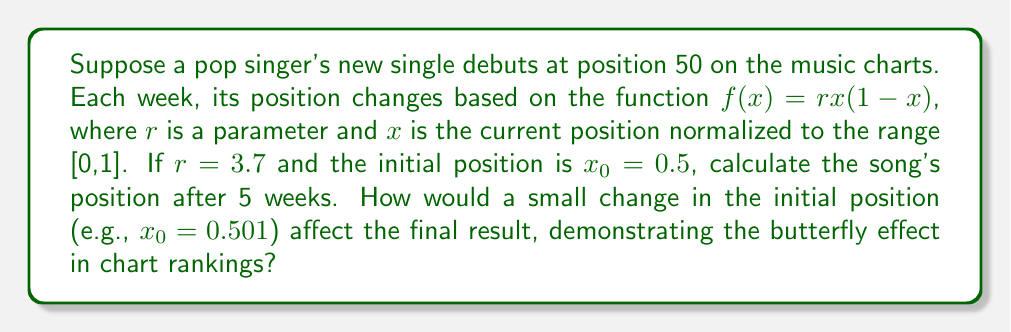Give your solution to this math problem. 1. Normalize the initial position:
   $x_0 = 50/100 = 0.5$

2. Use the logistic map equation $x_{n+1} = rx_n(1-x_n)$ with $r = 3.7$:

   Week 1: $x_1 = 3.7 \cdot 0.5 \cdot (1-0.5) = 0.925$
   Week 2: $x_2 = 3.7 \cdot 0.925 \cdot (1-0.925) = 0.256$
   Week 3: $x_3 = 3.7 \cdot 0.256 \cdot (1-0.256) = 0.706$
   Week 4: $x_4 = 3.7 \cdot 0.706 \cdot (1-0.706) = 0.769$
   Week 5: $x_5 = 3.7 \cdot 0.769 \cdot (1-0.769) = 0.657$

3. Convert back to chart position:
   Final position = $0.657 \cdot 100 \approx 66$

4. Now, let's calculate with $x_0 = 0.501$:

   Week 1: $x_1 = 3.7 \cdot 0.501 \cdot (1-0.501) = 0.926$
   Week 2: $x_2 = 3.7 \cdot 0.926 \cdot (1-0.926) = 0.253$
   Week 3: $x_3 = 3.7 \cdot 0.253 \cdot (1-0.253) = 0.700$
   Week 4: $x_4 = 3.7 \cdot 0.700 \cdot (1-0.700) = 0.777$
   Week 5: $x_5 = 3.7 \cdot 0.777 \cdot (1-0.777) = 0.641$

5. Convert back to chart position:
   Final position with small change = $0.641 \cdot 100 \approx 64$

The small initial change of 0.001 resulted in a difference of 2 positions after 5 weeks, demonstrating the butterfly effect in chart rankings.
Answer: 66; small initial change leads to 2-position difference 